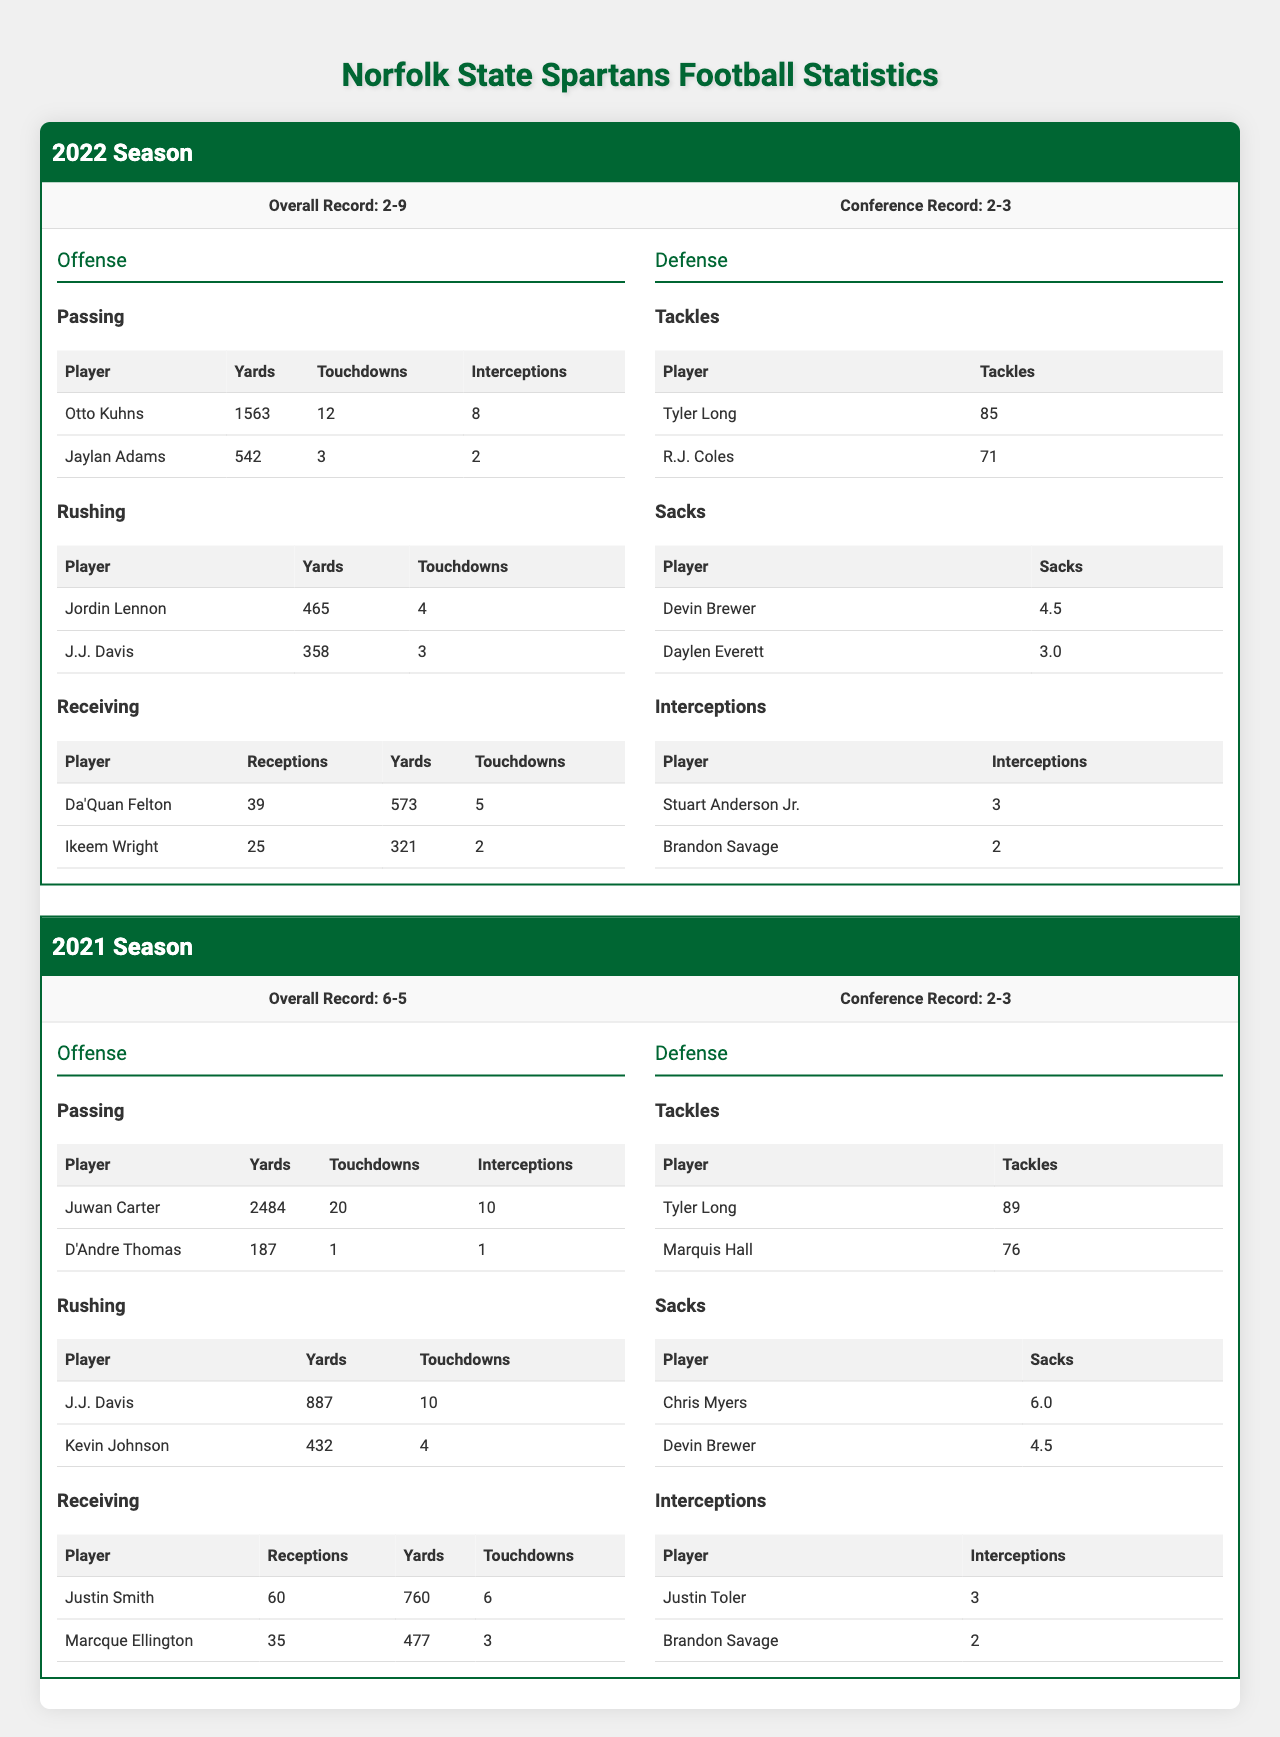What was the overall record of Norfolk State Spartans in the 2022 season? The table shows that the overall record for the 2022 season is listed directly under "Overall Record" for that season, which is "2-9."
Answer: 2-9 Who had the most passing yards in the 2021 season? Looking under the "Passing" category for the 2021 season, I see that Juwan Carter has 2484 yards, which is higher than D'Andre Thomas's 187 yards. Therefore, he had the most passing yards.
Answer: Juwan Carter What is the sum of rushing touchdowns for the 2021 season? In the "Rushing" category for the 2021 season, J.J. Davis has 10 touchdowns and Kevin Johnson has 4 touchdowns. Summing them gives 10 + 4 = 14.
Answer: 14 Did any player record more than 80 tackles in the 2022 season? Under the "Tackles" category for the 2022 season, Tyler Long has 85 tackles, which is greater than 80. Therefore, the answer is yes.
Answer: Yes Which season had the highest number of rushing yards by a player? In the 2021 season, J.J. Davis had 887 rushing yards, while in the 2022 season, Jordin Lennon had 465 rushing yards. 887 is greater than 465, indicating that the 2021 season had the highest number of rushing yards by a player.
Answer: 2021 Season What is the average number of receiving touchdowns for players in the 2022 season? The players Da'Quan Felton had 5 touchdowns, and Ikeem Wright had 2. Adding these together gives 5 + 2 = 7, and dividing by the number of players (2) gives an average of 7 / 2 = 3.5.
Answer: 3.5 How many players recorded interceptions in the 2021 season compared to the 2022 season? In 2021, there are 2 players listed (Justin Toler with 3 and Brandon Savage with 2) and in 2022 there are also 2 players (Stuart Anderson Jr. with 3 and Brandon Savage with 2). Therefore, the total number of players with interceptions is the same for both seasons.
Answer: Same (2 players) What is the difference in overall records between the 2021 and 2022 seasons? The overall record for the 2021 season is 6-5, which equates to 6 wins and 5 losses. The record for the 2022 season is 2-9, which equates to 2 wins and 9 losses. Calculating the difference in wins gives 6 - 2 = 4, and in losses gives 9 - 5 = 4. Thus, the overall difference is 4 wins and 4 losses.
Answer: 4 wins, 4 losses Which player had the most sacks in the 2021 season, and how many did they have? In the "Sacks" category for the 2021 season, Chris Myers has 6.0 sacks, which is more than Devin Brewer's 4.5 sacks. Therefore, Chris Myers had the most sacks in that season.
Answer: Chris Myers, 6.0 sacks 